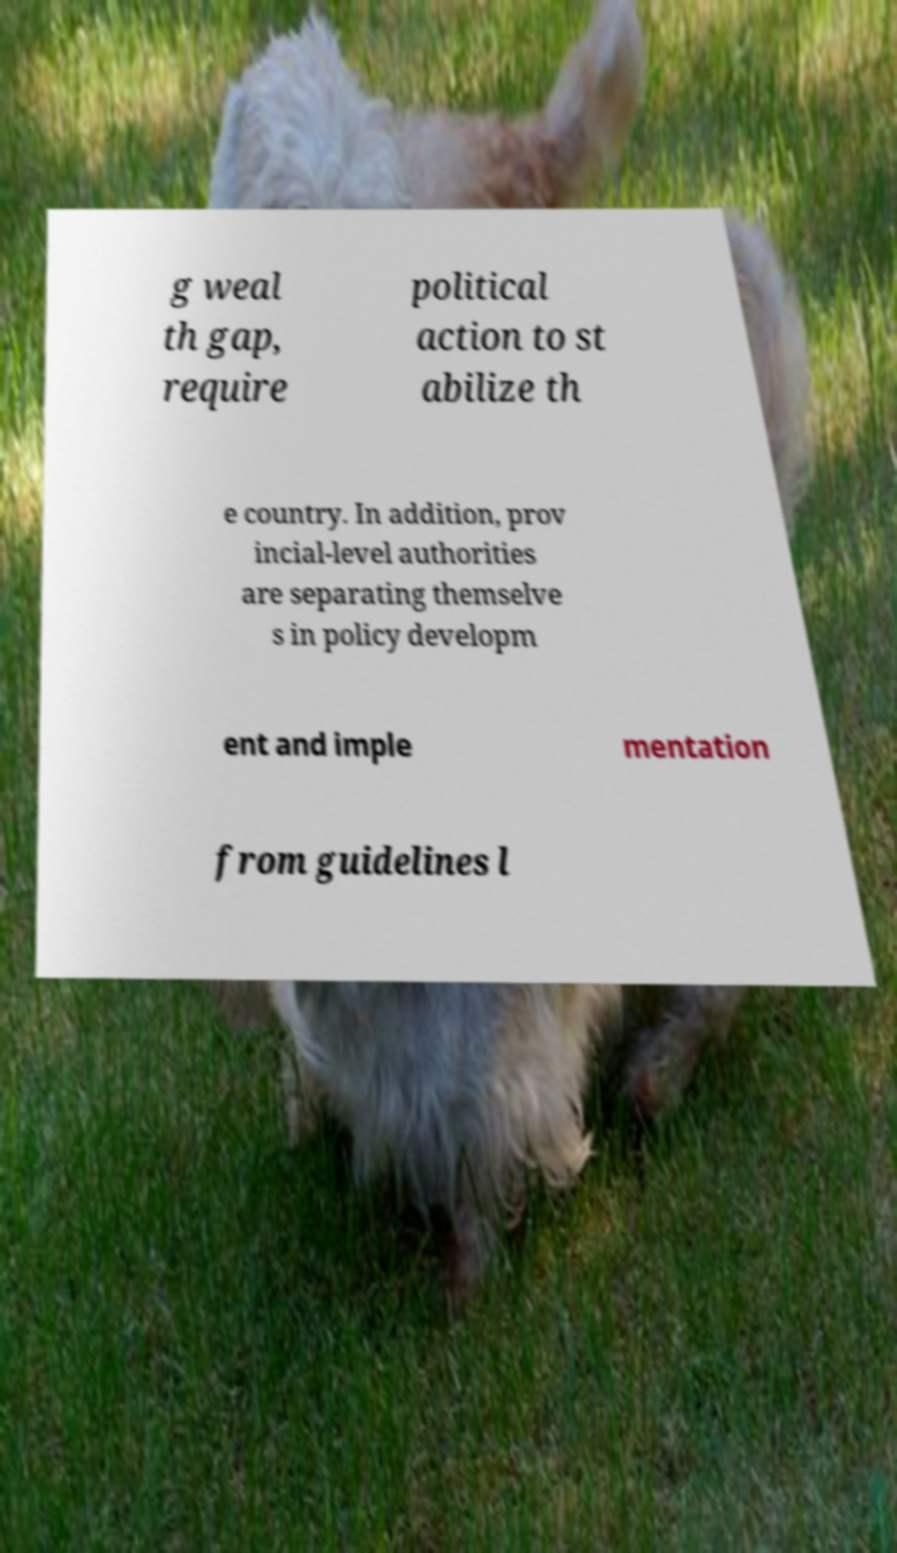Please read and relay the text visible in this image. What does it say? g weal th gap, require political action to st abilize th e country. In addition, prov incial-level authorities are separating themselve s in policy developm ent and imple mentation from guidelines l 